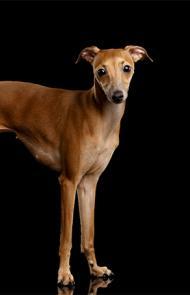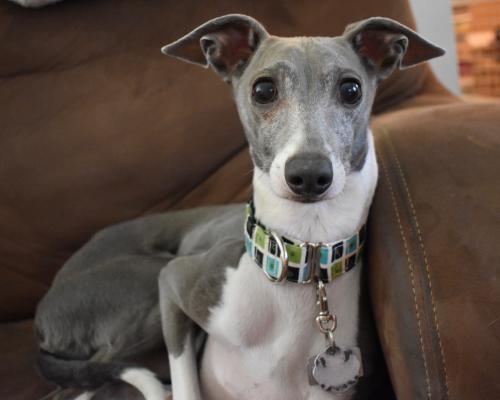The first image is the image on the left, the second image is the image on the right. Examine the images to the left and right. Is the description "An image shows a human limb touching a hound with its tongue hanging to the right." accurate? Answer yes or no. No. The first image is the image on the left, the second image is the image on the right. Considering the images on both sides, is "A dog is lying on the floor with its head up in the left image." valid? Answer yes or no. No. 